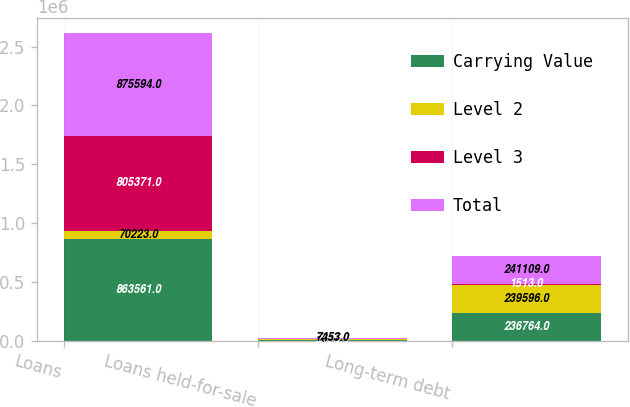<chart> <loc_0><loc_0><loc_500><loc_500><stacked_bar_chart><ecel><fcel>Loans<fcel>Loans held-for-sale<fcel>Long-term debt<nl><fcel>Carrying Value<fcel>863561<fcel>7453<fcel>236764<nl><fcel>Level 2<fcel>70223<fcel>5347<fcel>239596<nl><fcel>Level 3<fcel>805371<fcel>2106<fcel>1513<nl><fcel>Total<fcel>875594<fcel>7453<fcel>241109<nl></chart> 